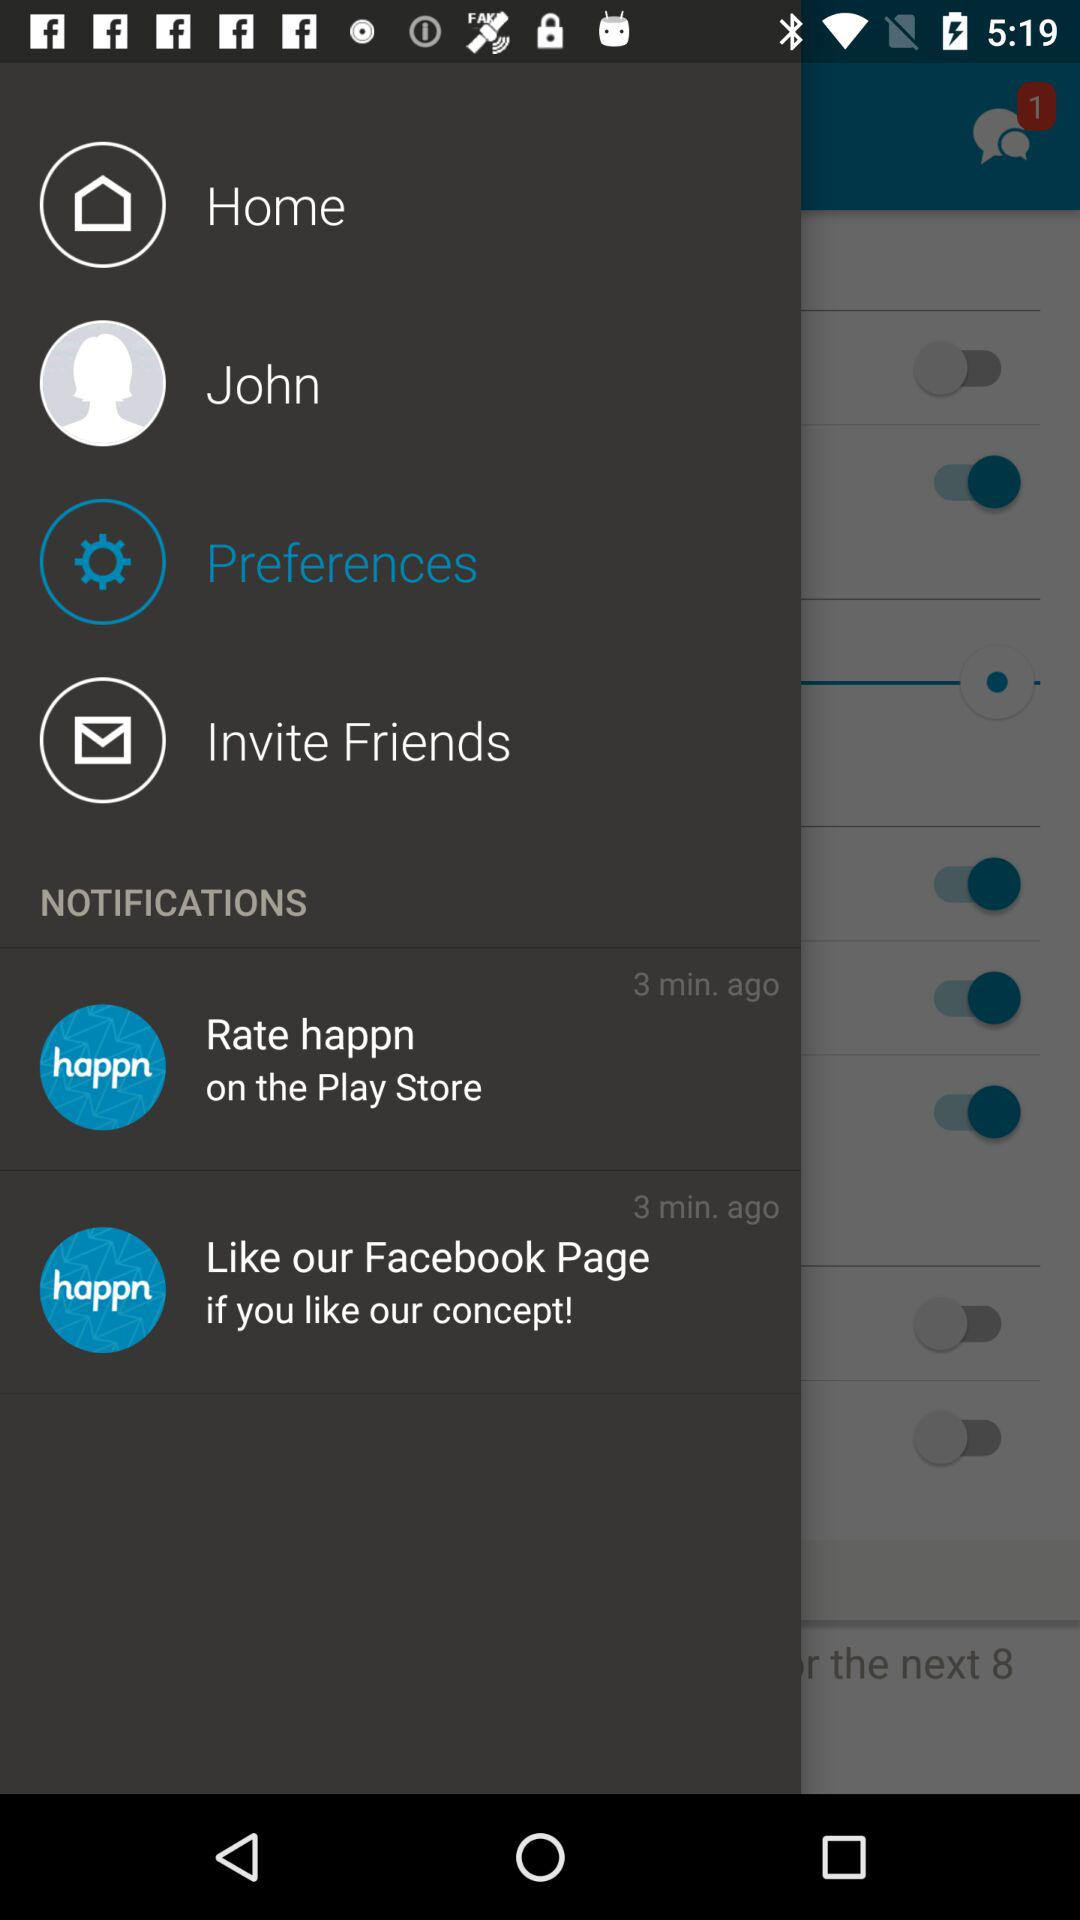Where can I rate the application? You can rate the application on the "Play Store". 